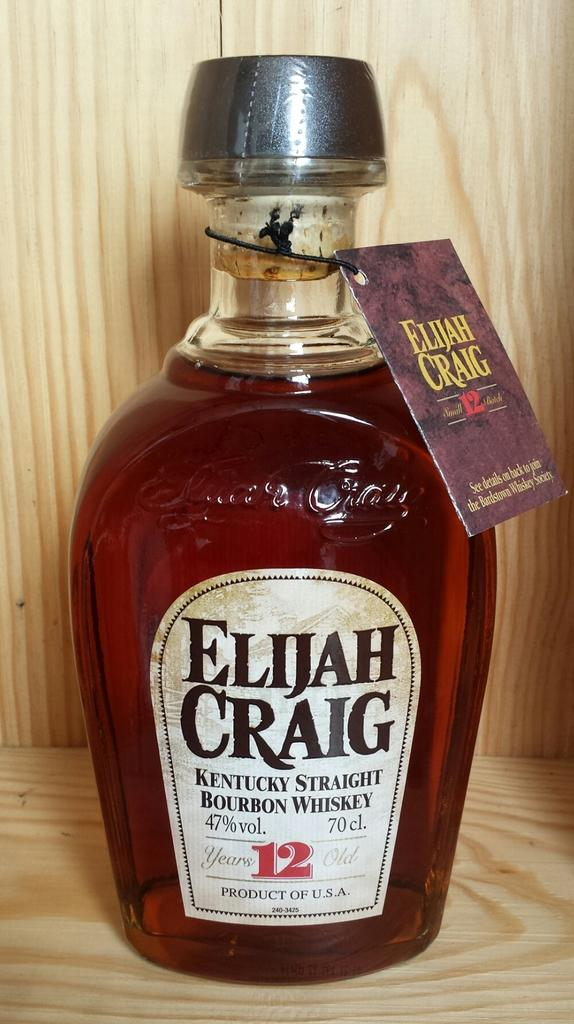<image>
Provide a brief description of the given image. A bottle of Elijah Craig Kentucky straight Bourbon Whiskey aged for 12 years. 